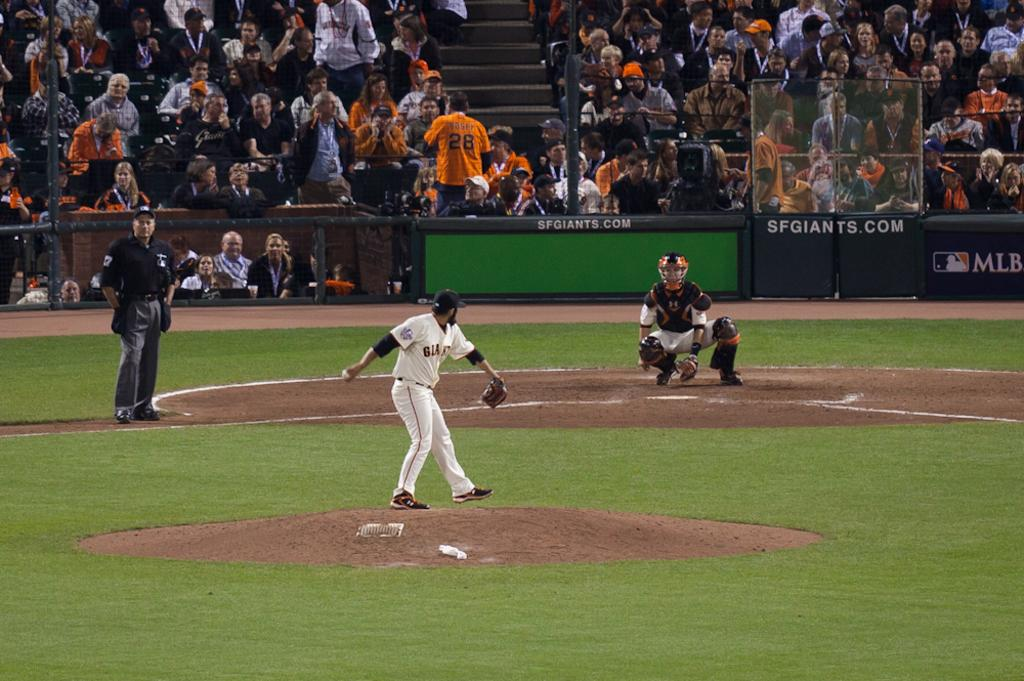Provide a one-sentence caption for the provided image. a pitcher throwing a ball while the backstop says sfgiants.com. 